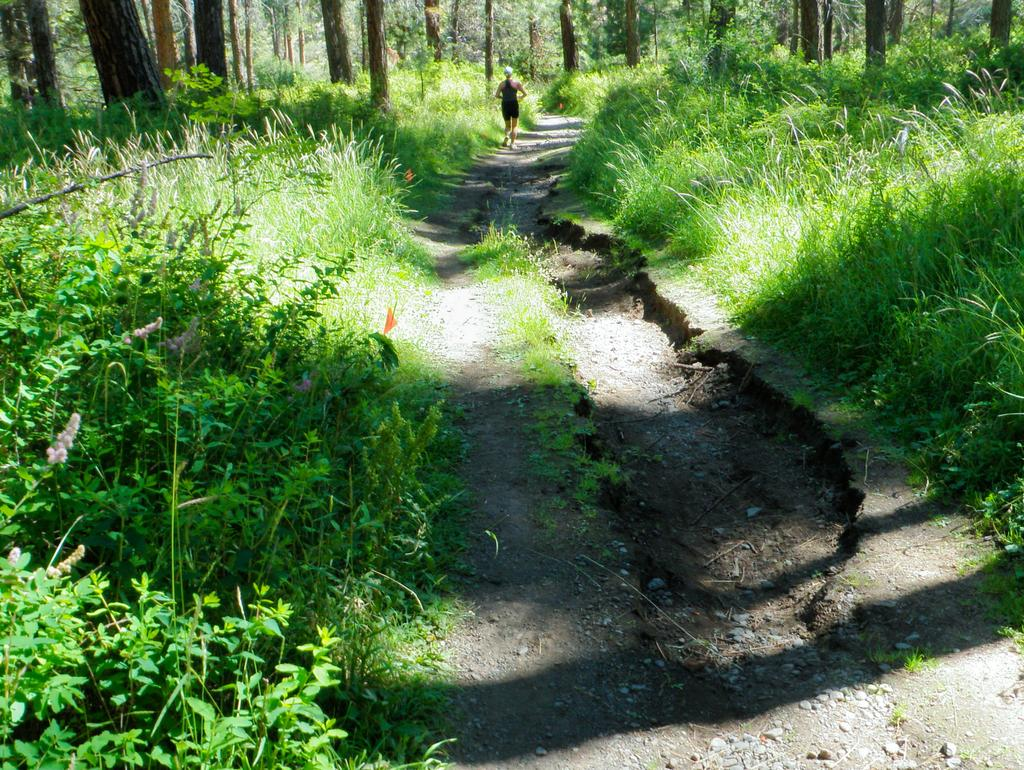What type of vegetation is present in the image? There are plants and trees in the image. Can you describe the person visible at the top of the image? Unfortunately, the provided facts do not give any information about the person visible at the top of the image. What type of soda is being used to water the plants in the image? There is no mention of soda being used to water the plants in the image. How does the person maintain their balance while standing at the top of the image? The provided facts do not give any information about the person's balance or the presence of any balancing objects in the image. 